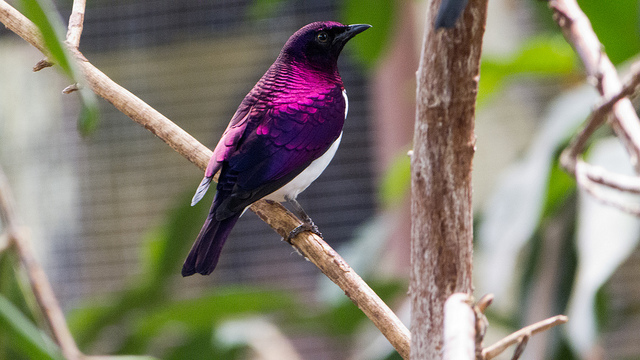What story could you weave around this bird's life? Once upon a time, in the heart of an African forest, there lived an Amethyst Starling named Amara. She was known far and wide for her stunning purple feathers that shimmered like the gemstones she was named after. Amara had a secret: she could navigate using the stars. Each night, she would fly beyond her usual territory, guided by the celestial patterns. Through her nightly journeys, she discovered hidden groves, met wise owls, and learned the ancient songs of the forest. Her adventures made her a legend among the woodland creatures, who would gather each dusk to hear tales of Amara's starlit escapades. What might be a challenge this bird faces in its environment? One significant challenge that the Amethyst Starling faces is habitat loss due to deforestation and land development. As human activities encroach on their natural habitats, these birds may find it increasingly difficult to locate food and suitable nesting sites. Additionally, climate change can disrupt their food supply and migratory patterns, posing further threats to their survival. Conservation efforts are crucial to ensuring that these vibrant birds can continue to thrive in their native environments. 